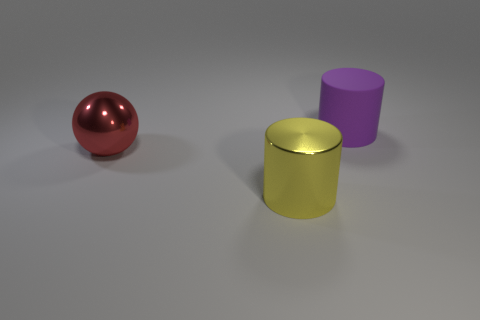Add 3 cylinders. How many objects exist? 6 Subtract all cylinders. How many objects are left? 1 Add 2 tiny cyan blocks. How many tiny cyan blocks exist? 2 Subtract 0 blue cylinders. How many objects are left? 3 Subtract all shiny spheres. Subtract all big rubber cylinders. How many objects are left? 1 Add 2 yellow objects. How many yellow objects are left? 3 